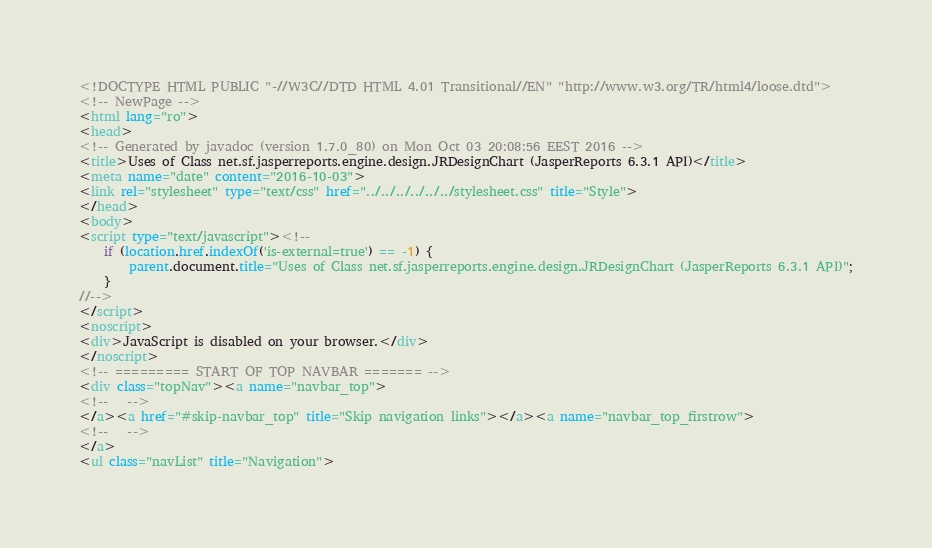Convert code to text. <code><loc_0><loc_0><loc_500><loc_500><_HTML_><!DOCTYPE HTML PUBLIC "-//W3C//DTD HTML 4.01 Transitional//EN" "http://www.w3.org/TR/html4/loose.dtd">
<!-- NewPage -->
<html lang="ro">
<head>
<!-- Generated by javadoc (version 1.7.0_80) on Mon Oct 03 20:08:56 EEST 2016 -->
<title>Uses of Class net.sf.jasperreports.engine.design.JRDesignChart (JasperReports 6.3.1 API)</title>
<meta name="date" content="2016-10-03">
<link rel="stylesheet" type="text/css" href="../../../../../../stylesheet.css" title="Style">
</head>
<body>
<script type="text/javascript"><!--
    if (location.href.indexOf('is-external=true') == -1) {
        parent.document.title="Uses of Class net.sf.jasperreports.engine.design.JRDesignChart (JasperReports 6.3.1 API)";
    }
//-->
</script>
<noscript>
<div>JavaScript is disabled on your browser.</div>
</noscript>
<!-- ========= START OF TOP NAVBAR ======= -->
<div class="topNav"><a name="navbar_top">
<!--   -->
</a><a href="#skip-navbar_top" title="Skip navigation links"></a><a name="navbar_top_firstrow">
<!--   -->
</a>
<ul class="navList" title="Navigation"></code> 